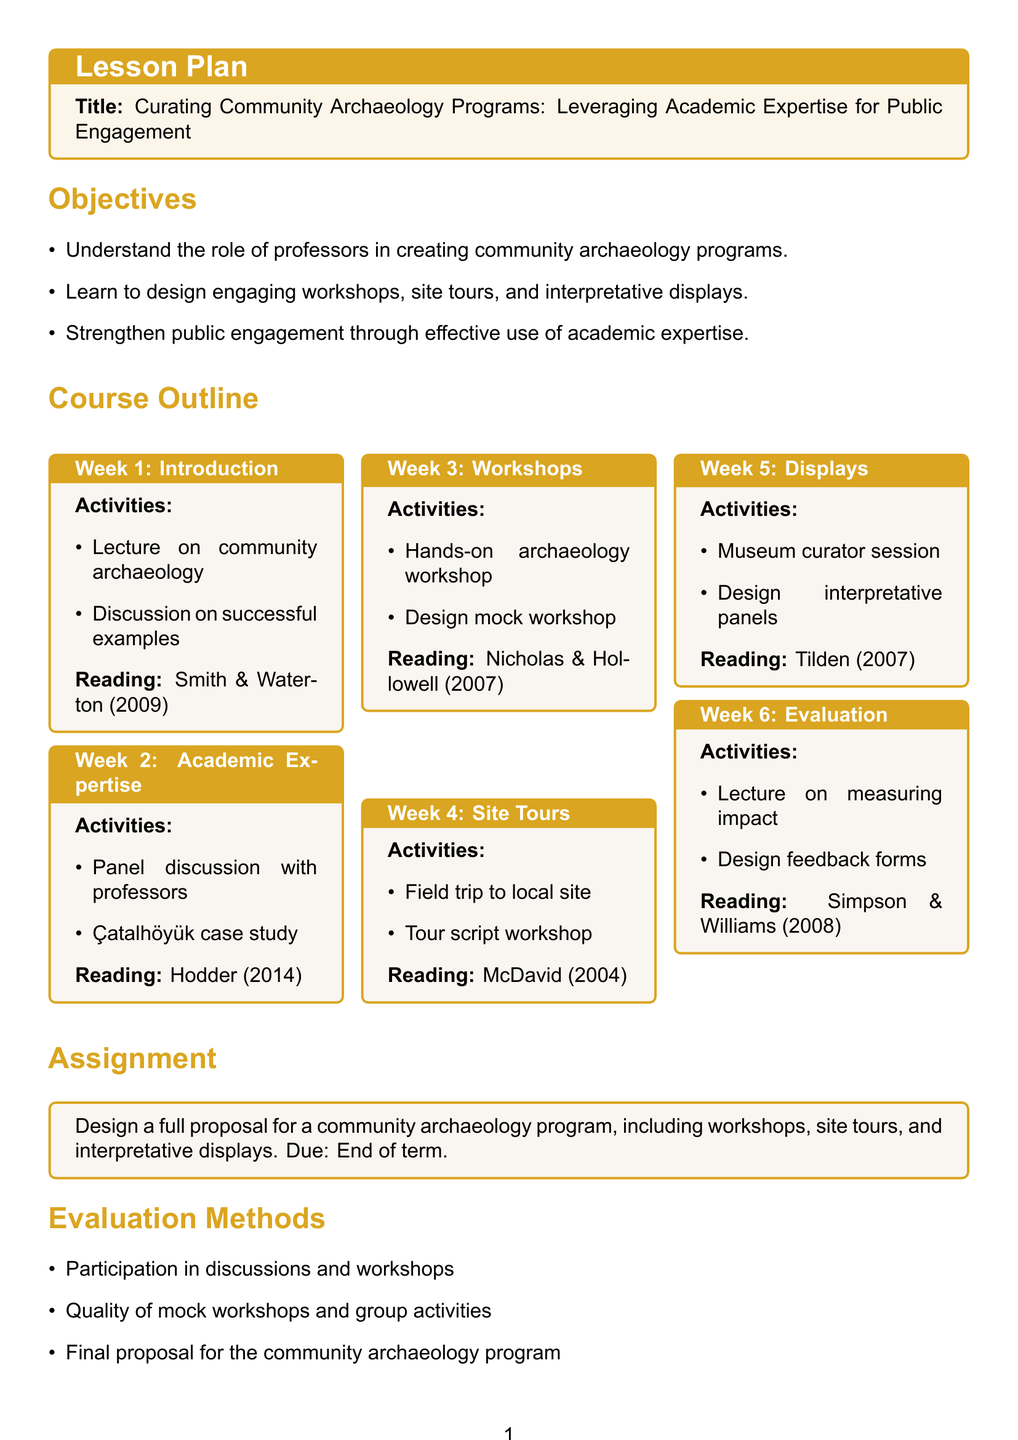what is the title of the lesson plan? The title is stated at the beginning of the document.
Answer: Curating Community Archaeology Programs: Leveraging Academic Expertise for Public Engagement how many weeks is the course outline? The outline divides the course into sections labeled as weeks, totaling six weeks.
Answer: 6 what is the focus of Week 3 activities? The activities for Week 3 are specifically about workshops.
Answer: Workshops who is featured in the panel discussion in Week 2? The panel discussion includes professors focusing on their contributions.
Answer: Professors which reading is assigned for Week 5? The document lists a specific reading related to interpretative displays in Week 5.
Answer: Tilden (2007) what is the main assignment for the course? The main assignment requires a specific proposal related to community archaeology.
Answer: Design a full proposal for a community archaeology program which week includes site tours? The week dedicated to site tours is outlined in a specific section of the course.
Answer: Week 4 what is the evaluation based on? Evaluation methods include several participatory elements as detailed in the lesson plan.
Answer: Participation in discussions and workshops 